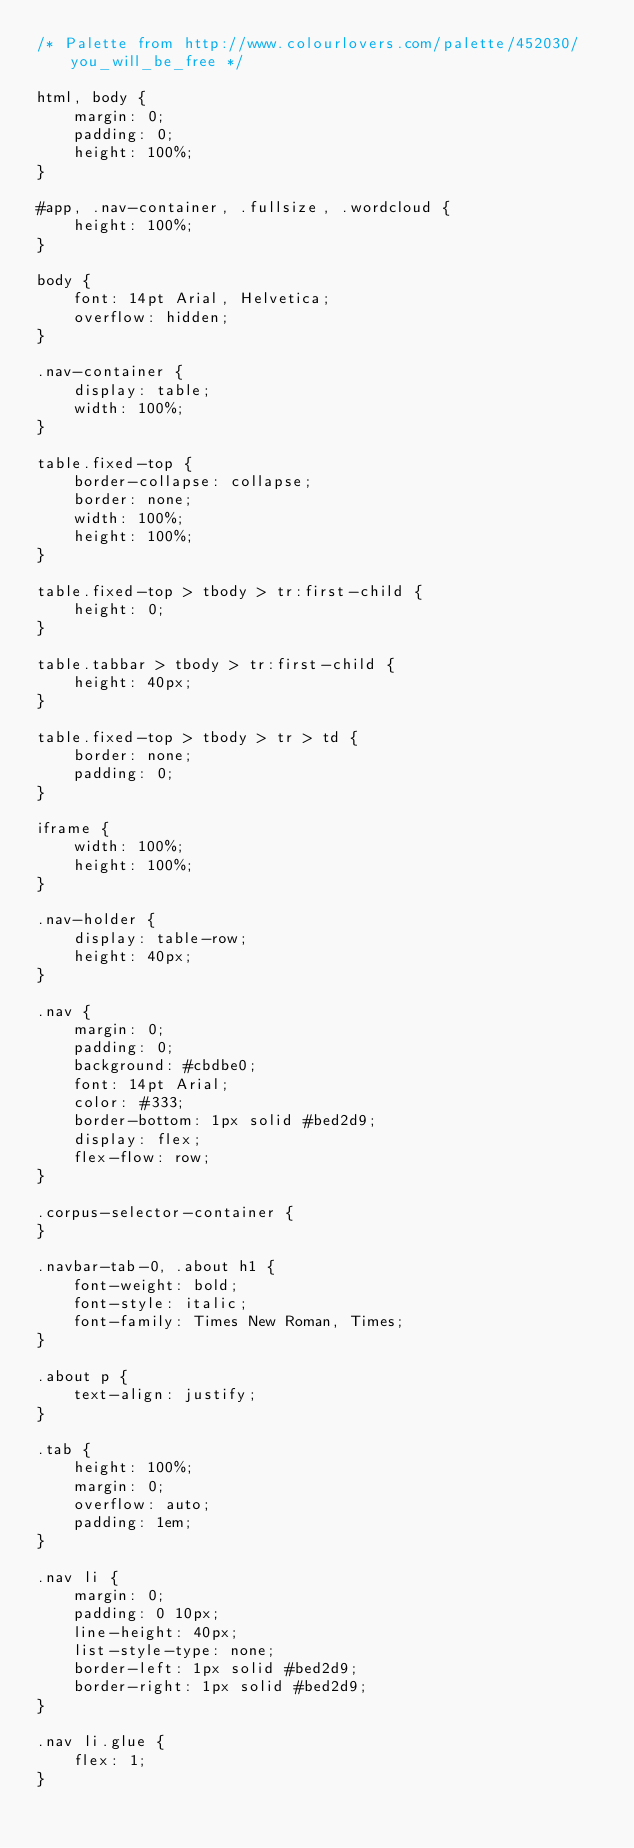Convert code to text. <code><loc_0><loc_0><loc_500><loc_500><_CSS_>/* Palette from http://www.colourlovers.com/palette/452030/you_will_be_free */

html, body {
    margin: 0;
    padding: 0;
    height: 100%;
}

#app, .nav-container, .fullsize, .wordcloud {
    height: 100%;
}

body {
    font: 14pt Arial, Helvetica;
    overflow: hidden;
}

.nav-container {
    display: table;
    width: 100%;
}

table.fixed-top {
    border-collapse: collapse;
    border: none;
    width: 100%;
    height: 100%;
}

table.fixed-top > tbody > tr:first-child {
    height: 0;
}

table.tabbar > tbody > tr:first-child {
    height: 40px;
}

table.fixed-top > tbody > tr > td {
    border: none;
    padding: 0;
}

iframe {
    width: 100%;
    height: 100%;
}

.nav-holder {
    display: table-row;
    height: 40px;
}

.nav {
    margin: 0;
    padding: 0;
    background: #cbdbe0;
    font: 14pt Arial;
    color: #333;
    border-bottom: 1px solid #bed2d9;
    display: flex;
    flex-flow: row;
}

.corpus-selector-container {
}

.navbar-tab-0, .about h1 {
    font-weight: bold;
    font-style: italic;
    font-family: Times New Roman, Times;
}

.about p {
    text-align: justify;
}

.tab {
    height: 100%;
    margin: 0;
    overflow: auto;
    padding: 1em;
}

.nav li {
    margin: 0;
    padding: 0 10px;
    line-height: 40px;
    list-style-type: none;
    border-left: 1px solid #bed2d9;
    border-right: 1px solid #bed2d9;
}

.nav li.glue {
    flex: 1;
}
</code> 